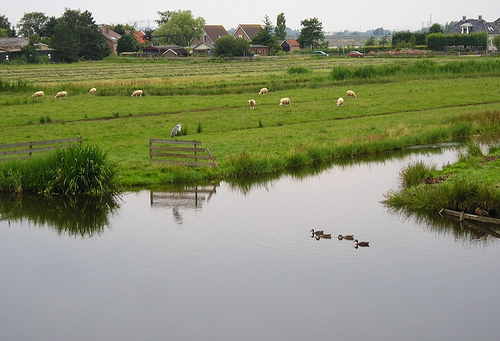<image>
Can you confirm if the bush is to the left of the shed? No. The bush is not to the left of the shed. From this viewpoint, they have a different horizontal relationship. 